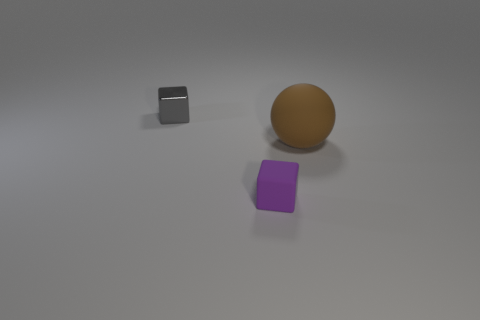Subtract all gray cubes. How many cubes are left? 1 Add 1 balls. How many objects exist? 4 Subtract all balls. How many objects are left? 2 Subtract all yellow metallic cylinders. Subtract all matte cubes. How many objects are left? 2 Add 2 rubber things. How many rubber things are left? 4 Add 1 purple shiny cylinders. How many purple shiny cylinders exist? 1 Subtract 0 blue cubes. How many objects are left? 3 